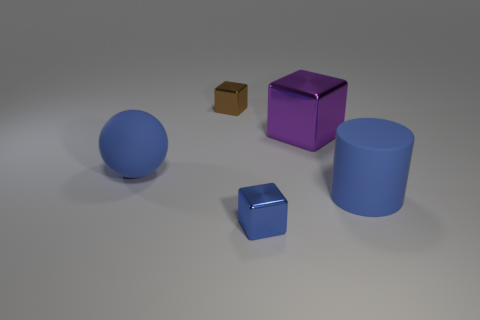Subtract all blue metal blocks. How many blocks are left? 2 Add 4 matte things. How many objects exist? 9 Subtract all cylinders. How many objects are left? 4 Subtract all blue cubes. How many cubes are left? 2 Subtract all purple metallic blocks. Subtract all blue objects. How many objects are left? 1 Add 3 small blue metallic blocks. How many small blue metallic blocks are left? 4 Add 2 large things. How many large things exist? 5 Subtract 0 red cylinders. How many objects are left? 5 Subtract all cyan spheres. Subtract all gray blocks. How many spheres are left? 1 